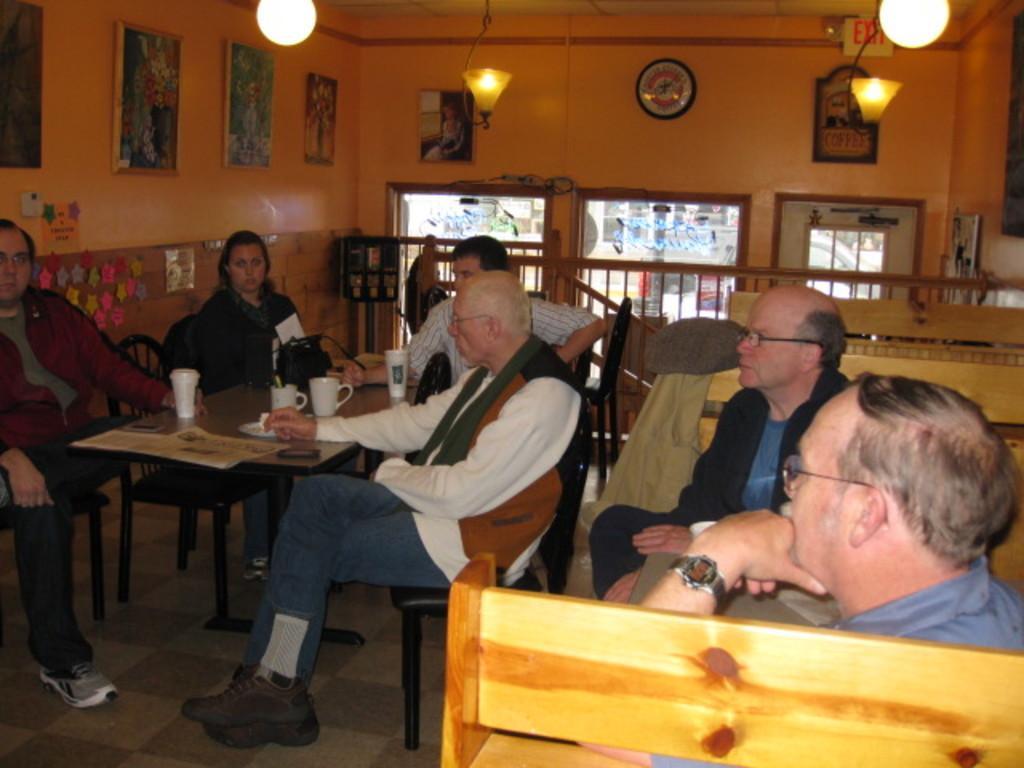Could you give a brief overview of what you see in this image? in this picture we can see a group of people sitting on chairs and in front of them on table we have glasses, cups, bags and in the background we can see wall with frames, clock, stickers and fence and from window we can see a car. 